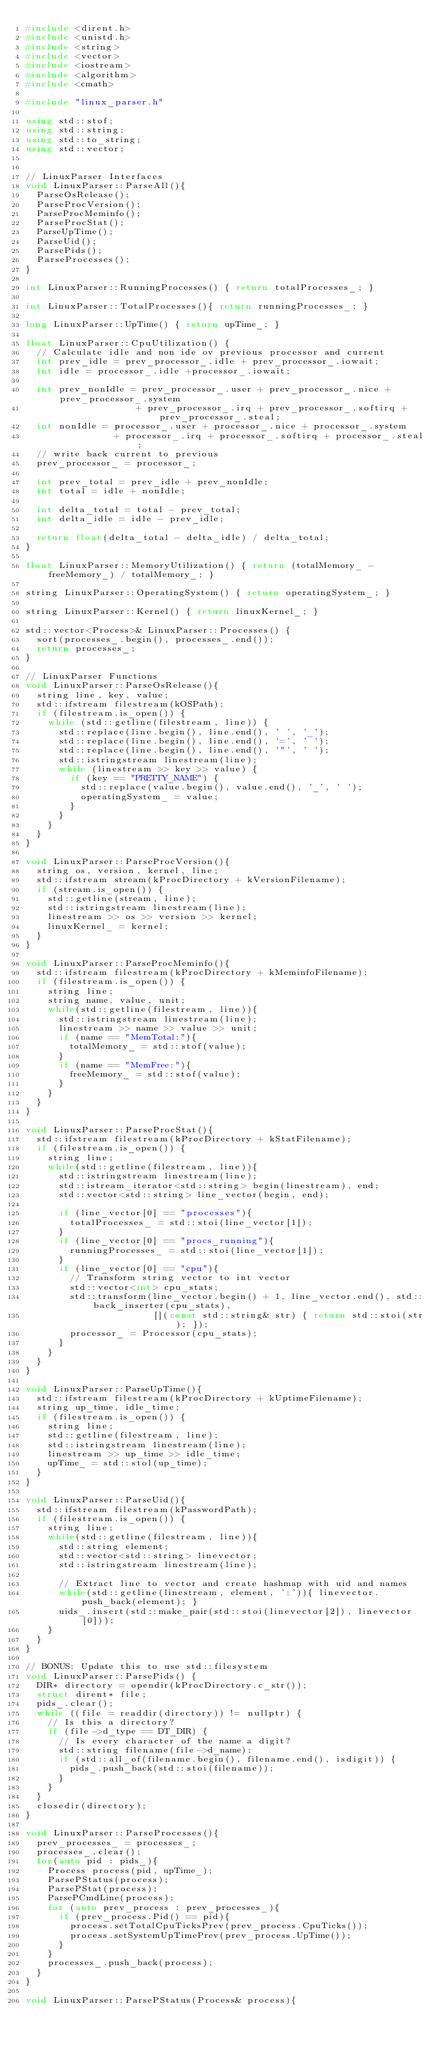Convert code to text. <code><loc_0><loc_0><loc_500><loc_500><_C++_>#include <dirent.h>
#include <unistd.h>
#include <string>
#include <vector>
#include <iostream>
#include <algorithm>
#include <cmath>

#include "linux_parser.h"

using std::stof;
using std::string;
using std::to_string;
using std::vector;


// LinuxParser Interfaces
void LinuxParser::ParseAll(){
  ParseOsRelease();
  ParseProcVersion();
  ParseProcMeminfo();
  ParseProcStat();
  ParseUpTime();
  ParseUid();
  ParsePids();
  ParseProcesses();   
}

int LinuxParser::RunningProcesses() { return totalProcesses_; }

int LinuxParser::TotalProcesses(){ return runningProcesses_; }

long LinuxParser::UpTime() { return upTime_; }

float LinuxParser::CpuUtilization() {
  // Calculate idle and non ide ov previous processor and current
  int prev_idle = prev_processor_.idle + prev_processor_.iowait;
  int idle = processor_.idle +processor_.iowait;

  int prev_nonIdle = prev_processor_.user + prev_processor_.nice + prev_processor_.system
                    + prev_processor_.irq + prev_processor_.softirq + prev_processor_.steal;
  int nonIdle = processor_.user + processor_.nice + processor_.system
                + processor_.irq + processor_.softirq + processor_.steal;
  // write back current to previous 
  prev_processor_ = processor_;
  
  int prev_total = prev_idle + prev_nonIdle;
  int total = idle + nonIdle;

  int delta_total = total - prev_total;
  int delta_idle = idle - prev_idle;

  return float(delta_total - delta_idle) / delta_total;
}

float LinuxParser::MemoryUtilization() { return (totalMemory_ - freeMemory_) / totalMemory_; }

string LinuxParser::OperatingSystem() { return operatingSystem_; }

string LinuxParser::Kernel() { return linuxKernel_; }

std::vector<Process>& LinuxParser::Processes() { 
  sort(processes_.begin(), processes_.end());
  return processes_; 
}

// LinuxParser Functions
void LinuxParser::ParseOsRelease(){
  string line, key, value;
  std::ifstream filestream(kOSPath);
  if (filestream.is_open()) {
    while (std::getline(filestream, line)) {
      std::replace(line.begin(), line.end(), ' ', '_');
      std::replace(line.begin(), line.end(), '=', ' ');
      std::replace(line.begin(), line.end(), '"', ' ');
      std::istringstream linestream(line);
      while (linestream >> key >> value) {
        if (key == "PRETTY_NAME") {
          std::replace(value.begin(), value.end(), '_', ' ');
          operatingSystem_ = value;
        }
      }
    }
  }
}

void LinuxParser::ParseProcVersion(){
  string os, version, kernel, line;
  std::ifstream stream(kProcDirectory + kVersionFilename);
  if (stream.is_open()) {
    std::getline(stream, line);
    std::istringstream linestream(line);
    linestream >> os >> version >> kernel;
    linuxKernel_ = kernel;
  }
}

void LinuxParser::ParseProcMeminfo(){
  std::ifstream filestream(kProcDirectory + kMeminfoFilename);
  if (filestream.is_open()) {
    string line;
    string name, value, unit;
    while(std::getline(filestream, line)){
      std::istringstream linestream(line);
      linestream >> name >> value >> unit;
      if (name == "MemTotal:"){
        totalMemory_ = std::stof(value);
      }
      if (name == "MemFree:"){
        freeMemory_ = std::stof(value);
      }
    }
  }
}

void LinuxParser::ParseProcStat(){
  std::ifstream filestream(kProcDirectory + kStatFilename);
  if (filestream.is_open()) {
    string line;
    while(std::getline(filestream, line)){
      std::istringstream linestream(line);
      std::istream_iterator<std::string> begin(linestream), end;
      std::vector<std::string> line_vector(begin, end);
      
      if (line_vector[0] == "processes"){
        totalProcesses_ = std::stoi(line_vector[1]);
      }
      if (line_vector[0] == "procs_running"){
        runningProcesses_ = std::stoi(line_vector[1]);
      }
      if (line_vector[0] == "cpu"){
        // Transform string vector to int vector
        std::vector<int> cpu_stats;
        std::transform(line_vector.begin() + 1, line_vector.end(), std::back_inserter(cpu_stats),
                       [](const std::string& str) { return std::stoi(str); });
        processor_ = Processor(cpu_stats);
      }
    }
  }
}

void LinuxParser::ParseUpTime(){
  std::ifstream filestream(kProcDirectory + kUptimeFilename);
  string up_time, idle_time;
  if (filestream.is_open()) {
    string line;
    std::getline(filestream, line);
    std::istringstream linestream(line);
    linestream >> up_time >> idle_time;
    upTime_ = std::stol(up_time);
  }
}

void LinuxParser::ParseUid(){
  std::ifstream filestream(kPasswordPath);
  if (filestream.is_open()) {
    string line;
    while(std::getline(filestream, line)){
      std::string element;
      std::vector<std::string> linevector;
      std::istringstream linestream(line);
      
      // Extract line to vector and create hashmap with uid and names
      while(std::getline(linestream, element, ':')){ linevector.push_back(element); }
      uids_.insert(std::make_pair(std::stoi(linevector[2]), linevector[0]));
    }
  }
}

// BONUS: Update this to use std::filesystem
void LinuxParser::ParsePids() {
  DIR* directory = opendir(kProcDirectory.c_str());
  struct dirent* file;
  pids_.clear();
  while ((file = readdir(directory)) != nullptr) {
    // Is this a directory?
    if (file->d_type == DT_DIR) {
      // Is every character of the name a digit?
      std::string filename(file->d_name);
      if (std::all_of(filename.begin(), filename.end(), isdigit)) {
        pids_.push_back(std::stoi(filename));
      }
    }
  }
  closedir(directory);
}

void LinuxParser::ParseProcesses(){
  prev_processes_ = processes_;
  processes_.clear();
  for(auto pid : pids_){
    Process process(pid, upTime_);
    ParsePStatus(process);
    ParsePStat(process);
    ParsePCmdLine(process);
    for (auto prev_process : prev_processes_){
      if (prev_process.Pid() == pid){
        process.setTotalCpuTicksPrev(prev_process.CpuTicks());
        process.setSystemUpTimePrev(prev_process.UpTime());
      }
    }
    processes_.push_back(process);
  }
}

void LinuxParser::ParsePStatus(Process& process){</code> 